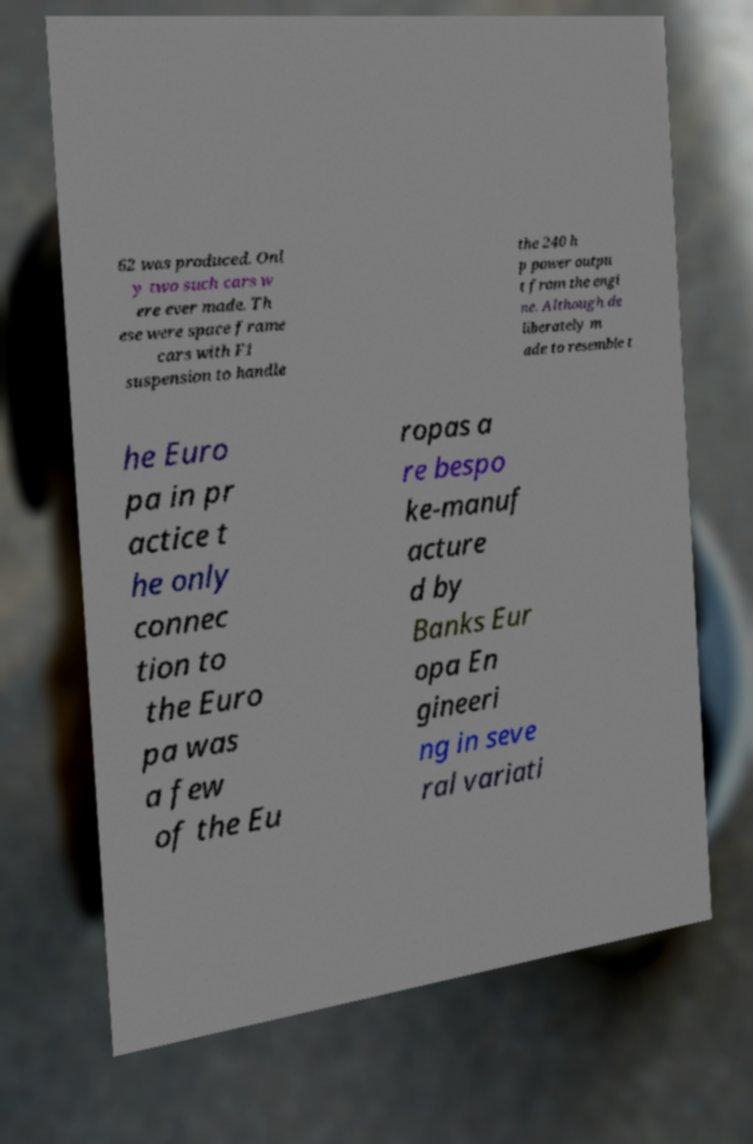For documentation purposes, I need the text within this image transcribed. Could you provide that? 62 was produced. Onl y two such cars w ere ever made. Th ese were space frame cars with F1 suspension to handle the 240 h p power outpu t from the engi ne. Although de liberately m ade to resemble t he Euro pa in pr actice t he only connec tion to the Euro pa was a few of the Eu ropas a re bespo ke-manuf acture d by Banks Eur opa En gineeri ng in seve ral variati 